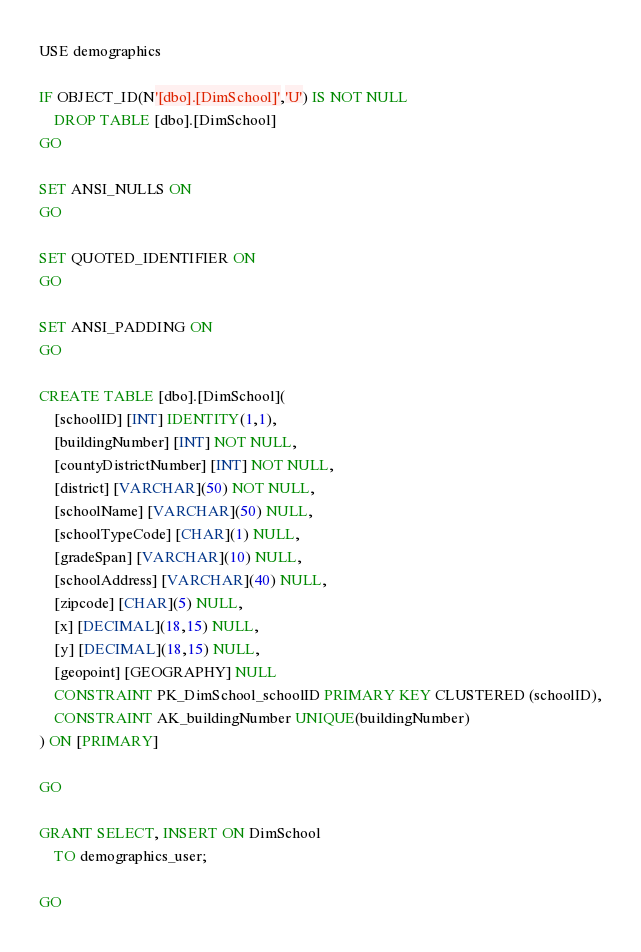<code> <loc_0><loc_0><loc_500><loc_500><_SQL_>USE demographics

IF OBJECT_ID(N'[dbo].[DimSchool]','U') IS NOT NULL
	DROP TABLE [dbo].[DimSchool]
GO

SET ANSI_NULLS ON
GO

SET QUOTED_IDENTIFIER ON
GO

SET ANSI_PADDING ON
GO

CREATE TABLE [dbo].[DimSchool](
	[schoolID] [INT] IDENTITY(1,1),
	[buildingNumber] [INT] NOT NULL,
	[countyDistrictNumber] [INT] NOT NULL,	
	[district] [VARCHAR](50) NOT NULL,
	[schoolName] [VARCHAR](50) NULL,
	[schoolTypeCode] [CHAR](1) NULL,
	[gradeSpan] [VARCHAR](10) NULL,
	[schoolAddress] [VARCHAR](40) NULL,
	[zipcode] [CHAR](5) NULL,
	[x] [DECIMAL](18,15) NULL,
	[y] [DECIMAL](18,15) NULL,
	[geopoint] [GEOGRAPHY] NULL
	CONSTRAINT PK_DimSchool_schoolID PRIMARY KEY CLUSTERED (schoolID),
	CONSTRAINT AK_buildingNumber UNIQUE(buildingNumber) 
) ON [PRIMARY]

GO

GRANT SELECT, INSERT ON DimSchool
	TO demographics_user;

GO</code> 